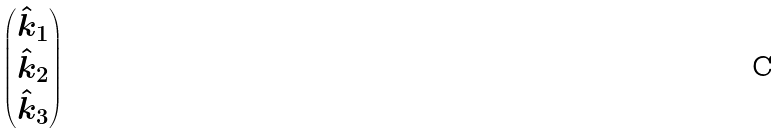<formula> <loc_0><loc_0><loc_500><loc_500>\begin{pmatrix} \hat { k } _ { 1 } \\ \hat { k } _ { 2 } \\ \hat { k } _ { 3 } \end{pmatrix}</formula> 